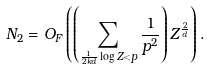<formula> <loc_0><loc_0><loc_500><loc_500>N _ { 2 } = O _ { F } \left ( \left ( \sum _ { \frac { 1 } { 2 k d } \log Z < p } \frac { 1 } { p ^ { 2 } } \right ) Z ^ { \frac { 2 } { d } } \right ) .</formula> 